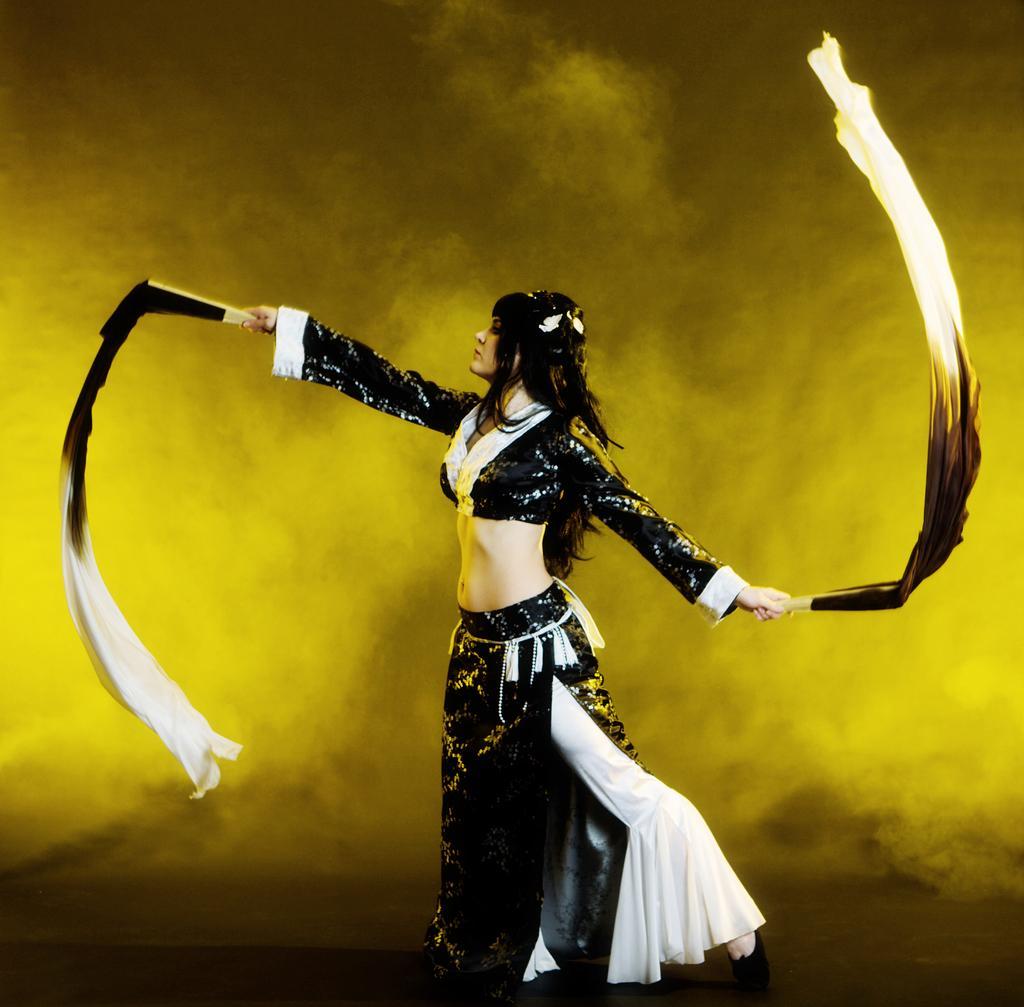In one or two sentences, can you explain what this image depicts? In this image, we can see a person on the yellow background. This person is holding clothes with her hands. 